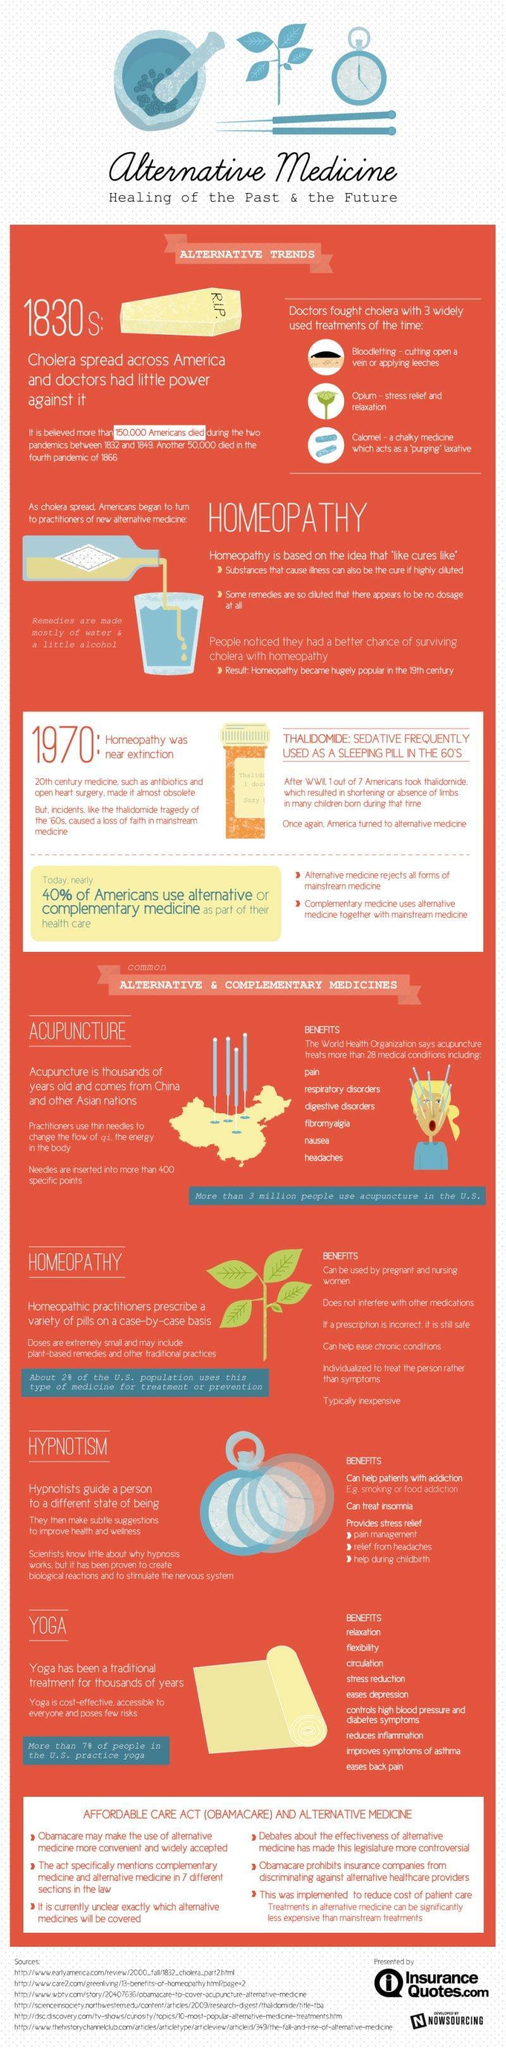How many benefits for homeopathy
Answer the question with a short phrase. 6 What is written on the coffin R.I.P. What were the 3 treatment methods used by doctors to fight cholera bloodletting, opium, calomel Other than yoga, what are the other alternative & complementary medicines Acupuncture, Homeopathy, Hypnotism How many benefits for yoga 9 In which treatment do practioners use thin needles to change the flow of qi, the energy in the body acupuncture what is the colour of the yoga mat, yellow or blue yellow 